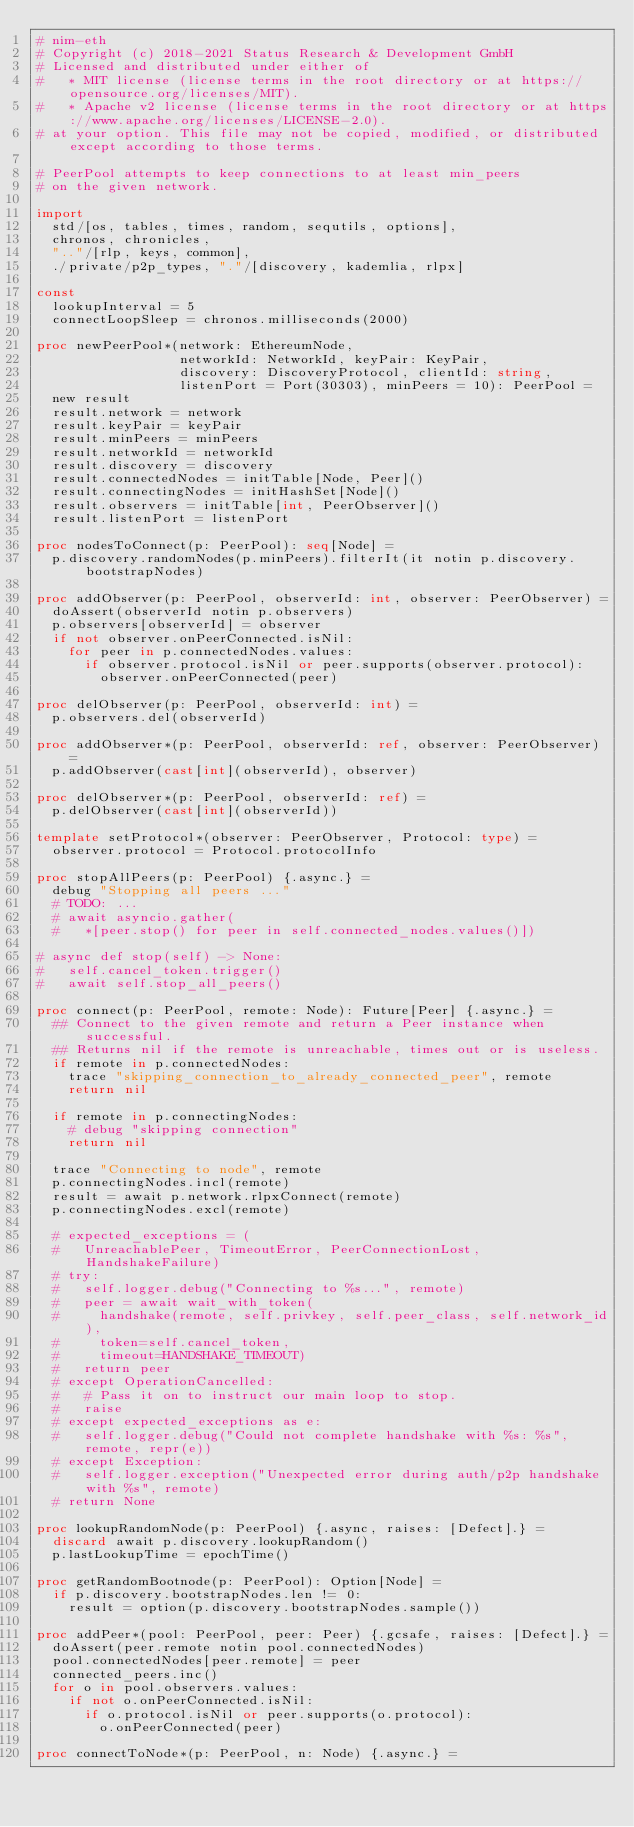<code> <loc_0><loc_0><loc_500><loc_500><_Nim_># nim-eth
# Copyright (c) 2018-2021 Status Research & Development GmbH
# Licensed and distributed under either of
#   * MIT license (license terms in the root directory or at https://opensource.org/licenses/MIT).
#   * Apache v2 license (license terms in the root directory or at https://www.apache.org/licenses/LICENSE-2.0).
# at your option. This file may not be copied, modified, or distributed except according to those terms.

# PeerPool attempts to keep connections to at least min_peers
# on the given network.

import
  std/[os, tables, times, random, sequtils, options],
  chronos, chronicles,
  ".."/[rlp, keys, common],
  ./private/p2p_types, "."/[discovery, kademlia, rlpx]

const
  lookupInterval = 5
  connectLoopSleep = chronos.milliseconds(2000)

proc newPeerPool*(network: EthereumNode,
                  networkId: NetworkId, keyPair: KeyPair,
                  discovery: DiscoveryProtocol, clientId: string,
                  listenPort = Port(30303), minPeers = 10): PeerPool =
  new result
  result.network = network
  result.keyPair = keyPair
  result.minPeers = minPeers
  result.networkId = networkId
  result.discovery = discovery
  result.connectedNodes = initTable[Node, Peer]()
  result.connectingNodes = initHashSet[Node]()
  result.observers = initTable[int, PeerObserver]()
  result.listenPort = listenPort

proc nodesToConnect(p: PeerPool): seq[Node] =
  p.discovery.randomNodes(p.minPeers).filterIt(it notin p.discovery.bootstrapNodes)

proc addObserver(p: PeerPool, observerId: int, observer: PeerObserver) =
  doAssert(observerId notin p.observers)
  p.observers[observerId] = observer
  if not observer.onPeerConnected.isNil:
    for peer in p.connectedNodes.values:
      if observer.protocol.isNil or peer.supports(observer.protocol):
        observer.onPeerConnected(peer)

proc delObserver(p: PeerPool, observerId: int) =
  p.observers.del(observerId)

proc addObserver*(p: PeerPool, observerId: ref, observer: PeerObserver) =
  p.addObserver(cast[int](observerId), observer)

proc delObserver*(p: PeerPool, observerId: ref) =
  p.delObserver(cast[int](observerId))

template setProtocol*(observer: PeerObserver, Protocol: type) =
  observer.protocol = Protocol.protocolInfo

proc stopAllPeers(p: PeerPool) {.async.} =
  debug "Stopping all peers ..."
  # TODO: ...
  # await asyncio.gather(
  #   *[peer.stop() for peer in self.connected_nodes.values()])

# async def stop(self) -> None:
#   self.cancel_token.trigger()
#   await self.stop_all_peers()

proc connect(p: PeerPool, remote: Node): Future[Peer] {.async.} =
  ## Connect to the given remote and return a Peer instance when successful.
  ## Returns nil if the remote is unreachable, times out or is useless.
  if remote in p.connectedNodes:
    trace "skipping_connection_to_already_connected_peer", remote
    return nil

  if remote in p.connectingNodes:
    # debug "skipping connection"
    return nil

  trace "Connecting to node", remote
  p.connectingNodes.incl(remote)
  result = await p.network.rlpxConnect(remote)
  p.connectingNodes.excl(remote)

  # expected_exceptions = (
  #   UnreachablePeer, TimeoutError, PeerConnectionLost, HandshakeFailure)
  # try:
  #   self.logger.debug("Connecting to %s...", remote)
  #   peer = await wait_with_token(
  #     handshake(remote, self.privkey, self.peer_class, self.network_id),
  #     token=self.cancel_token,
  #     timeout=HANDSHAKE_TIMEOUT)
  #   return peer
  # except OperationCancelled:
  #   # Pass it on to instruct our main loop to stop.
  #   raise
  # except expected_exceptions as e:
  #   self.logger.debug("Could not complete handshake with %s: %s", remote, repr(e))
  # except Exception:
  #   self.logger.exception("Unexpected error during auth/p2p handshake with %s", remote)
  # return None

proc lookupRandomNode(p: PeerPool) {.async, raises: [Defect].} =
  discard await p.discovery.lookupRandom()
  p.lastLookupTime = epochTime()

proc getRandomBootnode(p: PeerPool): Option[Node] =
  if p.discovery.bootstrapNodes.len != 0:
    result = option(p.discovery.bootstrapNodes.sample())

proc addPeer*(pool: PeerPool, peer: Peer) {.gcsafe, raises: [Defect].} =
  doAssert(peer.remote notin pool.connectedNodes)
  pool.connectedNodes[peer.remote] = peer
  connected_peers.inc()
  for o in pool.observers.values:
    if not o.onPeerConnected.isNil:
      if o.protocol.isNil or peer.supports(o.protocol):
        o.onPeerConnected(peer)

proc connectToNode*(p: PeerPool, n: Node) {.async.} =</code> 